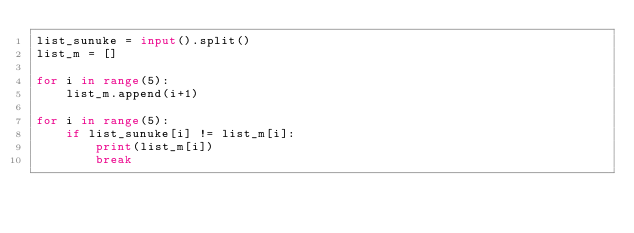<code> <loc_0><loc_0><loc_500><loc_500><_Python_>list_sunuke = input().split()
list_m = []

for i in range(5):
    list_m.append(i+1)

for i in range(5):
    if list_sunuke[i] != list_m[i]:
        print(list_m[i])
        break</code> 